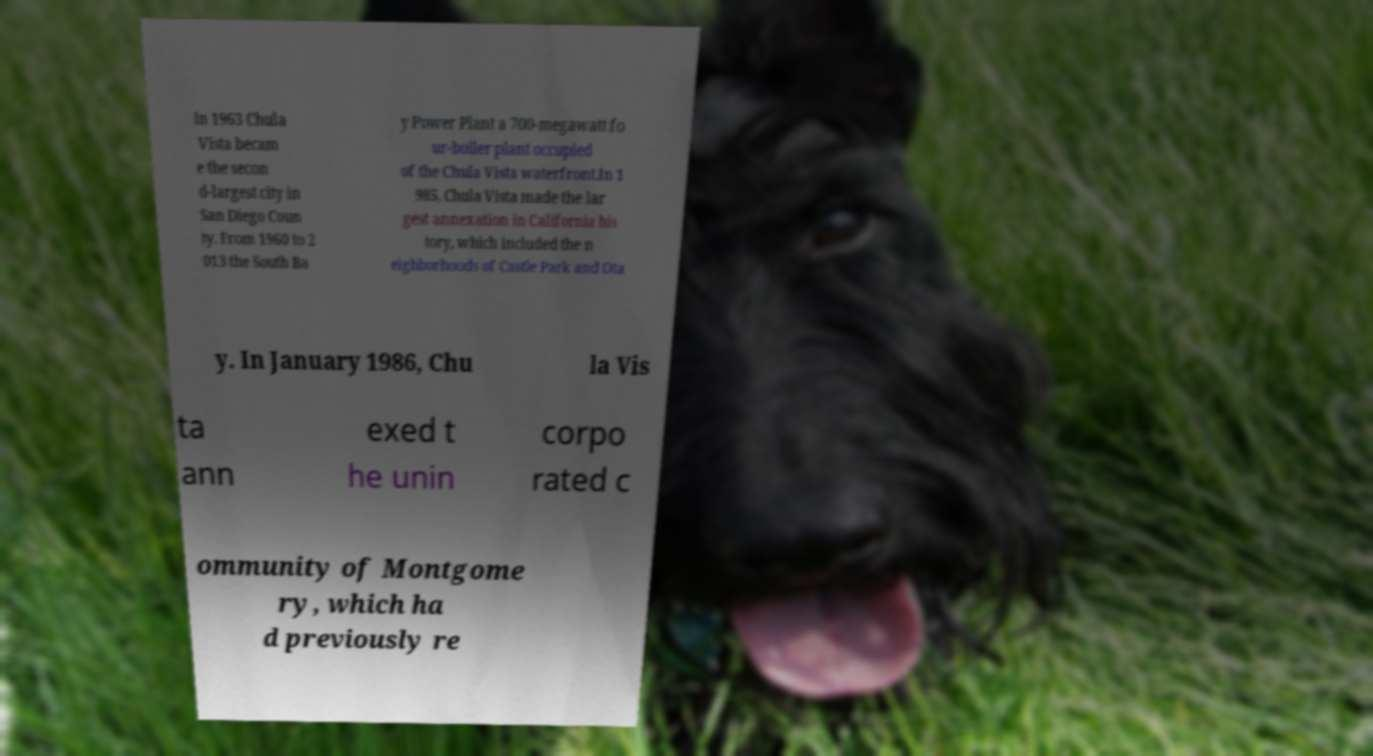What messages or text are displayed in this image? I need them in a readable, typed format. In 1963 Chula Vista becam e the secon d-largest city in San Diego Coun ty. From 1960 to 2 013 the South Ba y Power Plant a 700-megawatt fo ur-boiler plant occupied of the Chula Vista waterfront.In 1 985, Chula Vista made the lar gest annexation in California his tory, which included the n eighborhoods of Castle Park and Ota y. In January 1986, Chu la Vis ta ann exed t he unin corpo rated c ommunity of Montgome ry, which ha d previously re 